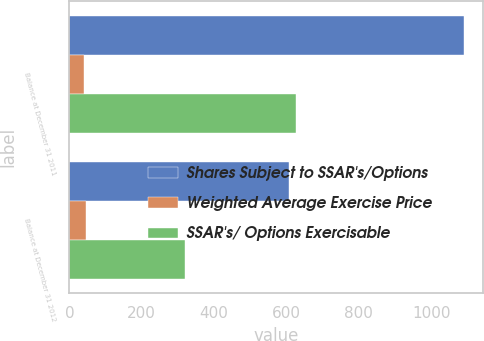<chart> <loc_0><loc_0><loc_500><loc_500><stacked_bar_chart><ecel><fcel>Balance at December 31 2011<fcel>Balance at December 31 2012<nl><fcel>Shares Subject to SSAR's/Options<fcel>1090<fcel>606<nl><fcel>Weighted Average Exercise Price<fcel>39.16<fcel>44.68<nl><fcel>SSAR's/ Options Exercisable<fcel>627<fcel>320<nl></chart> 